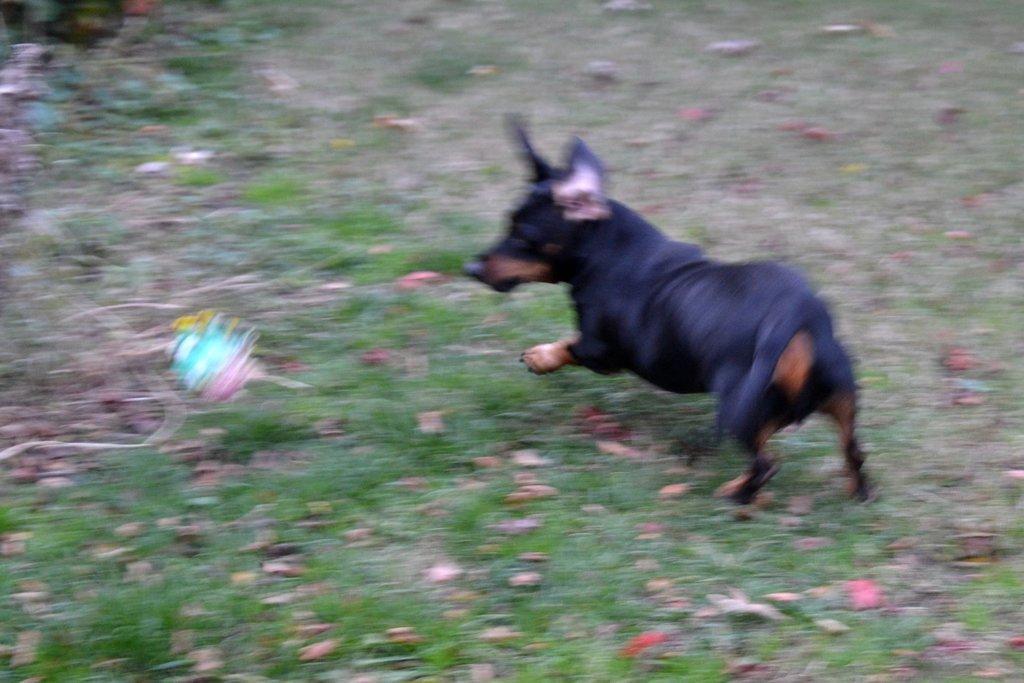Can you describe this image briefly? In the center of the image we can see a dog which is in black color. At the bottom there is grass. 